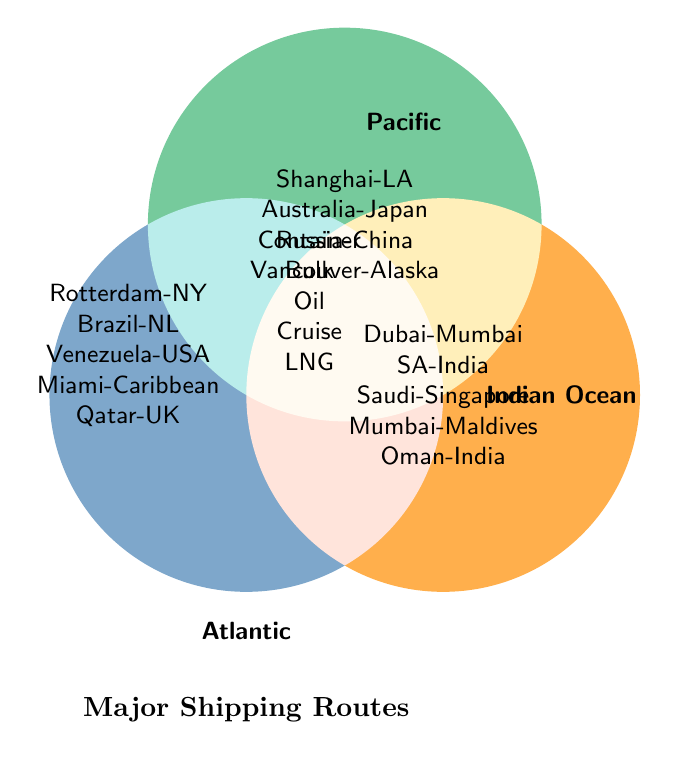How many total route types are depicted in the Atlantic Ocean section? Count the number of elements in the Atlantic Ocean section. There are five: "Rotterdam-NY", "Brazil-NL", "Venezuela-USA", "Miami-Caribbean", and "Qatar-UK".
Answer: 5 Which shipping routes are common between the Pacific and the Indian Ocean sections? Identify the routes presented in both the Pacific section ("Shanghai-LA", "Australia-Japan", "Russia-China", "Vancouver-Alaska") and Indian Ocean section ("Dubai-Mumbai", "SA-India", "Saudi-Singapore", "Mumbai-Maldives", "Oman-India"). None overlap.
Answer: None What is the southernmost route in the Pacific Ocean section? Among the routes listed, "Vancouver-Alaska" is the northernmost route, and of the remaining, "Australia-Japan" appears reasonable given its proximity to the Southern Hemisphere.
Answer: Australia-Japan Which type of shipping route has the most entries in any of the oceans? Count the entries per type across the three ocean sections. The "Pacific" has 4 entries (Container, Bulk Cargo, Oil Tankers, and Cruise Ships) while the "Atlantic" and "Indian Ocean" also tally 5 entries respectively.
Answer: Bulk Cargo Find the common route type across all three oceans. In the overlapped section of the Venn Diagram (the intersection area), the route types are listed as Container, Bulk, Oil, Cruise, and LNG, indicating these types exist in all three oceans.
Answer: Container, Bulk, Oil, Cruise, LNG How many unique routes are presented in the Indian Ocean section excluding intersections? List all routes in the Indian Ocean section ("Dubai-Mumbai", "SA-India", "Saudi-Singapore", "Mumbai-Maldives", "Oman-India") and confirm they do not overlap with other sections. All 5 routes are unique.
Answer: 5 